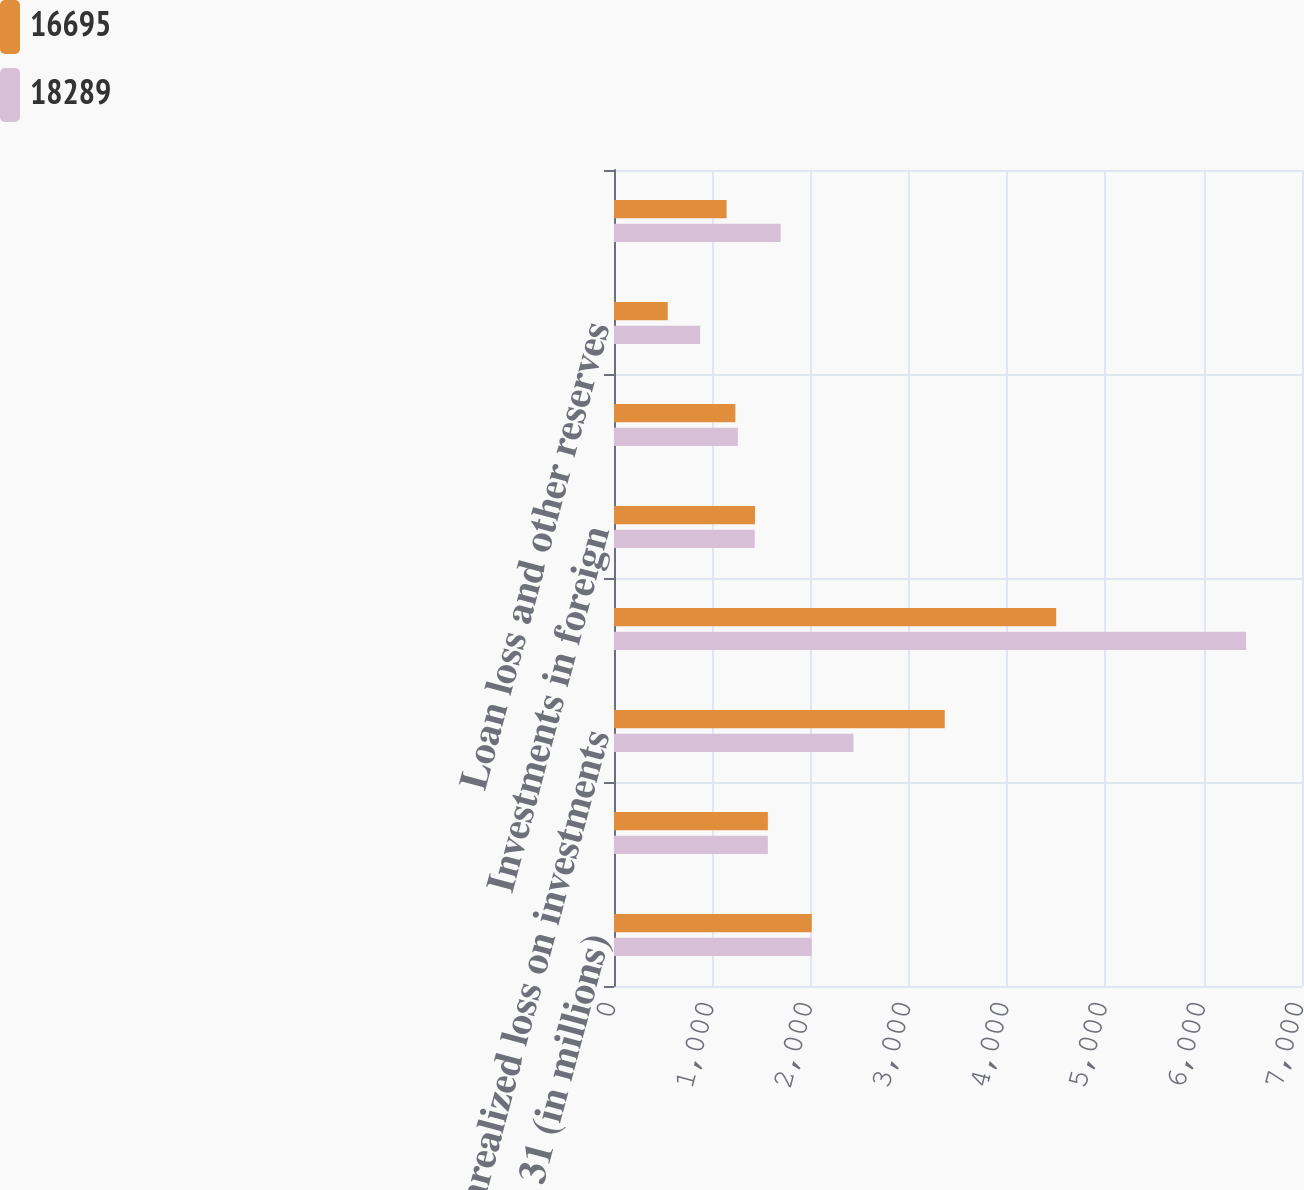<chart> <loc_0><loc_0><loc_500><loc_500><stacked_bar_chart><ecel><fcel>December 31 (in millions)<fcel>Losses and tax credit<fcel>Unrealized loss on investments<fcel>Accruals not currently<fcel>Investments in foreign<fcel>Loss reserve discount<fcel>Loan loss and other reserves<fcel>Unearned premium reserve<nl><fcel>16695<fcel>2012<fcel>1565.5<fcel>3365<fcel>4499<fcel>1435<fcel>1235<fcel>547<fcel>1145<nl><fcel>18289<fcel>2011<fcel>1565.5<fcel>2436<fcel>6431<fcel>1432<fcel>1260<fcel>877<fcel>1696<nl></chart> 